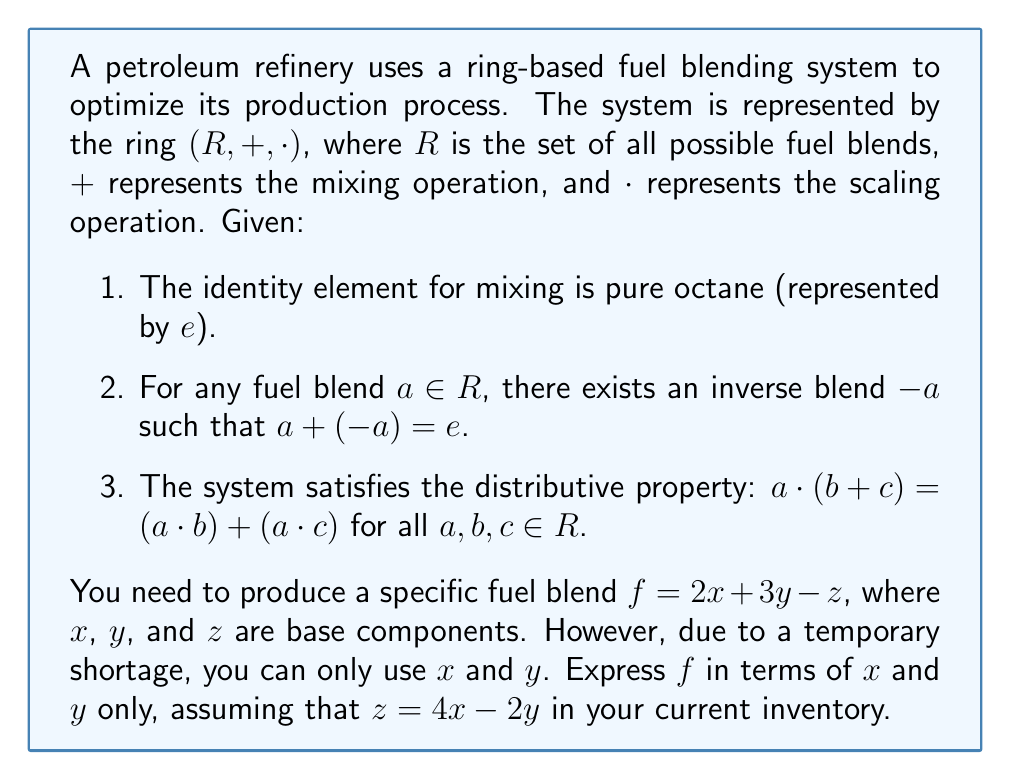Give your solution to this math problem. Let's approach this step-by-step using ring theory:

1) We start with the given fuel blend formula:
   $$f = 2x + 3y - z$$

2) We're told that $z = 4x - 2y$ in the current inventory. Let's substitute this into our formula:
   $$f = 2x + 3y - (4x - 2y)$$

3) Now, let's use the properties of ring theory to simplify this expression:

   a) First, distribute the negative sign:
      $$f = 2x + 3y + (-4x) + 2y$$

   b) In ring theory, $(-4x)$ is the same as $(-4) \cdot x$. The associative property allows us to regroup terms:
      $$f = (2x + (-4x)) + (3y + 2y)$$

   c) Simplify within the parentheses:
      $$f = (-2x) + 5y$$

4) Therefore, we have expressed $f$ in terms of only $x$ and $y$.

This result shows how ring theory can be applied to optimize fuel blending processes. By using the properties of rings (associativity, distributivity, and the existence of additive inverses), we can manipulate and simplify complex blend formulas, even when certain components are unavailable or need to be substituted.
Answer: $f = -2x + 5y$ 